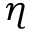Convert formula to latex. <formula><loc_0><loc_0><loc_500><loc_500>\eta</formula> 